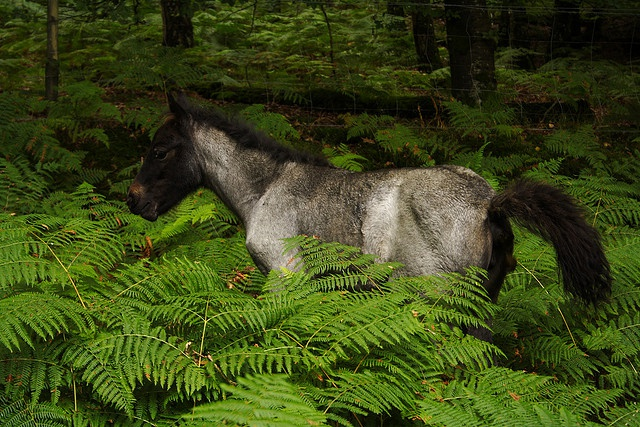Describe the objects in this image and their specific colors. I can see a horse in darkgreen, black, gray, and darkgray tones in this image. 